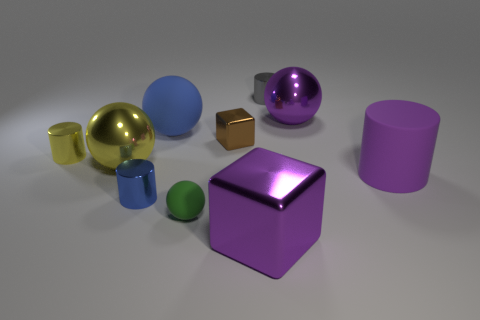Subtract all purple cylinders. How many cylinders are left? 3 Subtract all tiny blue cylinders. How many cylinders are left? 3 Subtract all spheres. How many objects are left? 6 Subtract all gray spheres. Subtract all yellow blocks. How many spheres are left? 4 Add 1 brown things. How many brown things exist? 2 Subtract 0 yellow blocks. How many objects are left? 10 Subtract all gray shiny things. Subtract all big yellow shiny things. How many objects are left? 8 Add 2 rubber cylinders. How many rubber cylinders are left? 3 